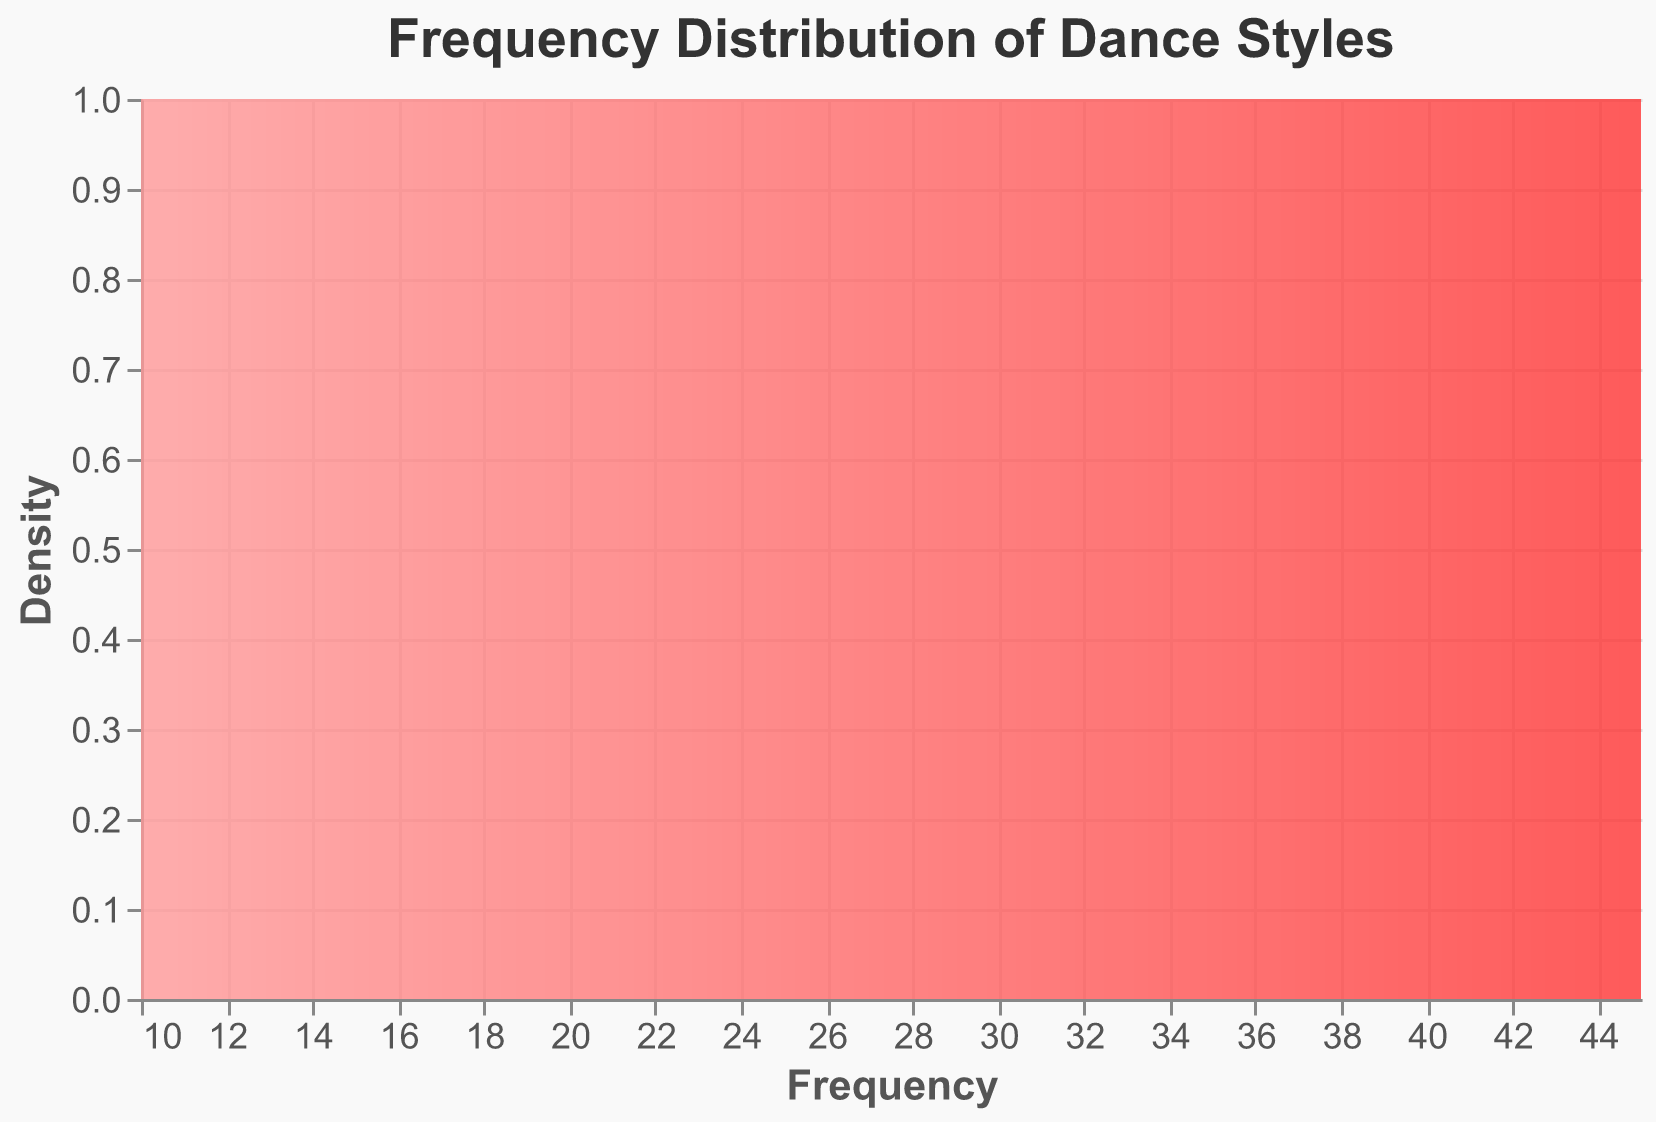How many dance styles are shown in the figure? Count the unique dance styles listed in the data. There are 15 unique dance styles.
Answer: 15 Which dance style has the highest frequency? Look at the dance style with the highest frequency value listed. Hip-Hop has the highest frequency of 45.
Answer: Hip-Hop What is the frequency of Zumba? Find the listing for Zumba in the data and refer to its frequency value. The frequency of Zumba is 33.
Answer: 33 How many dance styles have a frequency greater than 30? Count the number of dance styles where the frequency value is greater than 30. There are 4 dance styles with a frequency greater than 30: Hip-Hop, Line Dancing, Freestyle, and Zumba.
Answer: 4 Which dance style has a frequency equal to 22? Check the data for a dance style with a frequency of 22. Jazz has a frequency of 22.
Answer: Jazz What is the total frequency of all dance styles combined? Sum all the frequency values in the data. The sum of all frequencies is 45 + 30 + 20 + 15 + 25 + 35 + 10 + 18 + 22 + 28 + 40 + 33 + 12 + 17 + 14 = 364.
Answer: 364 What is the average frequency of dance styles? Divide the total frequency of all dance styles by the number of dance styles. The average frequency is 364/15 = 24.27.
Answer: 24.27 Which venue hosts the most frequent dance style? Identify the dance style with the highest frequency and then locate its corresponding venue. The highest frequency dance style is Hip-Hop (45), which is performed at Nightclub.
Answer: Nightclub What is the least frequent dance style, and where is it performed? Look for the dance style with the lowest frequency and note its venue. Ballet has the lowest frequency of 10 and is performed at the Theater.
Answer: Ballet, Theater What is the range of the frequencies of dance styles? Subtract the smallest frequency value from the largest frequency value. The range is 45 (highest frequency) - 10 (lowest frequency) = 35.
Answer: 35 